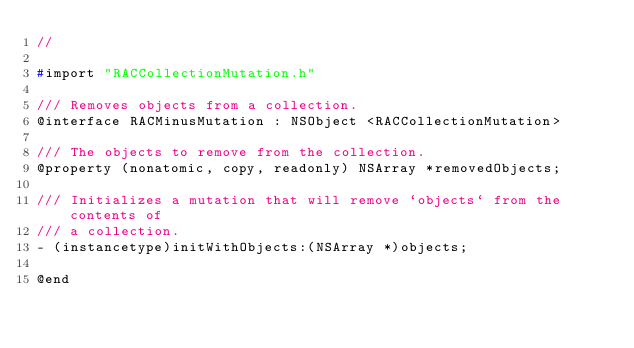Convert code to text. <code><loc_0><loc_0><loc_500><loc_500><_C_>//

#import "RACCollectionMutation.h"

/// Removes objects from a collection.
@interface RACMinusMutation : NSObject <RACCollectionMutation>

/// The objects to remove from the collection.
@property (nonatomic, copy, readonly) NSArray *removedObjects;

/// Initializes a mutation that will remove `objects` from the contents of
/// a collection.
- (instancetype)initWithObjects:(NSArray *)objects;

@end
</code> 